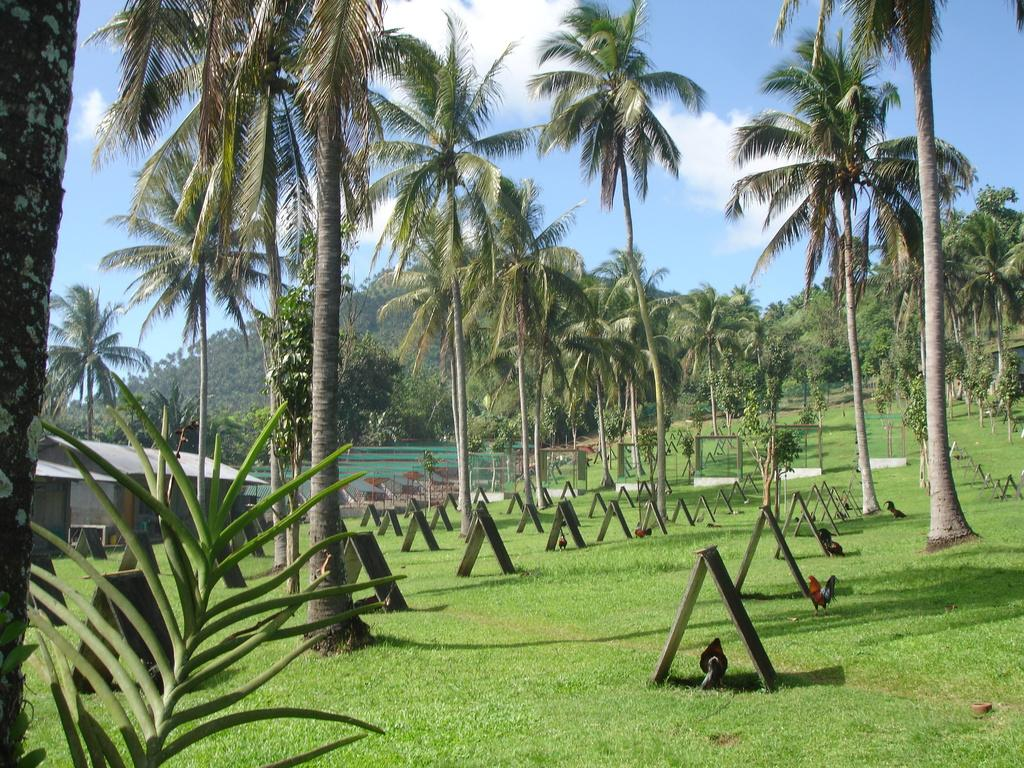What type of vegetation can be seen in the image? There are trees in the image. Where is the house located in the image? The house is on the left side of the image. What can be found on the ground in the image? There are roasters and plants on the ground in the image. What is the color and condition of the sky in the image? The sky is blue and cloudy in the image. What type of ground cover is present in the image? There is grass on the ground in the image. How many toothbrushes are visible in the image? There are no toothbrushes present in the image. What type of lamp is illuminating the area in the image? There is no lamp present in the image. 